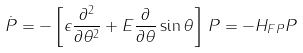Convert formula to latex. <formula><loc_0><loc_0><loc_500><loc_500>\dot { P } = - \left [ \epsilon \frac { \partial ^ { 2 } } { \partial \theta ^ { 2 } } + E \frac { \partial } { \partial \theta } \sin \theta \right ] \, P = - H _ { F P } P</formula> 